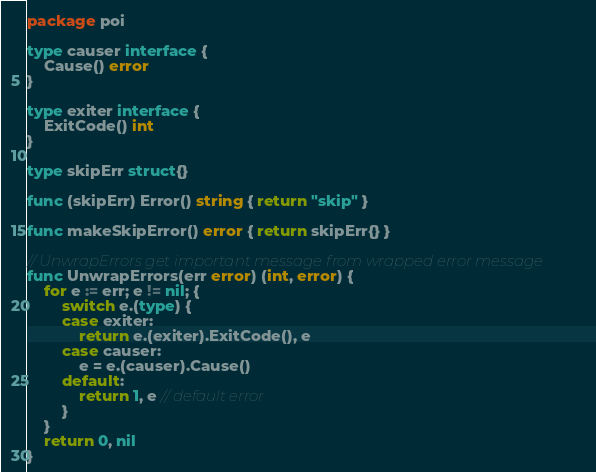<code> <loc_0><loc_0><loc_500><loc_500><_Go_>package poi

type causer interface {
	Cause() error
}

type exiter interface {
	ExitCode() int
}

type skipErr struct{}

func (skipErr) Error() string { return "skip" }

func makeSkipError() error { return skipErr{} }

// UnwrapErrors get important message from wrapped error message
func UnwrapErrors(err error) (int, error) {
	for e := err; e != nil; {
		switch e.(type) {
		case exiter:
			return e.(exiter).ExitCode(), e
		case causer:
			e = e.(causer).Cause()
		default:
			return 1, e // default error
		}
	}
	return 0, nil
}
</code> 